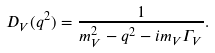Convert formula to latex. <formula><loc_0><loc_0><loc_500><loc_500>D _ { V } ( q ^ { 2 } ) = \frac { 1 } { m ^ { 2 } _ { V } - q ^ { 2 } - i m _ { V } \Gamma _ { V } } .</formula> 